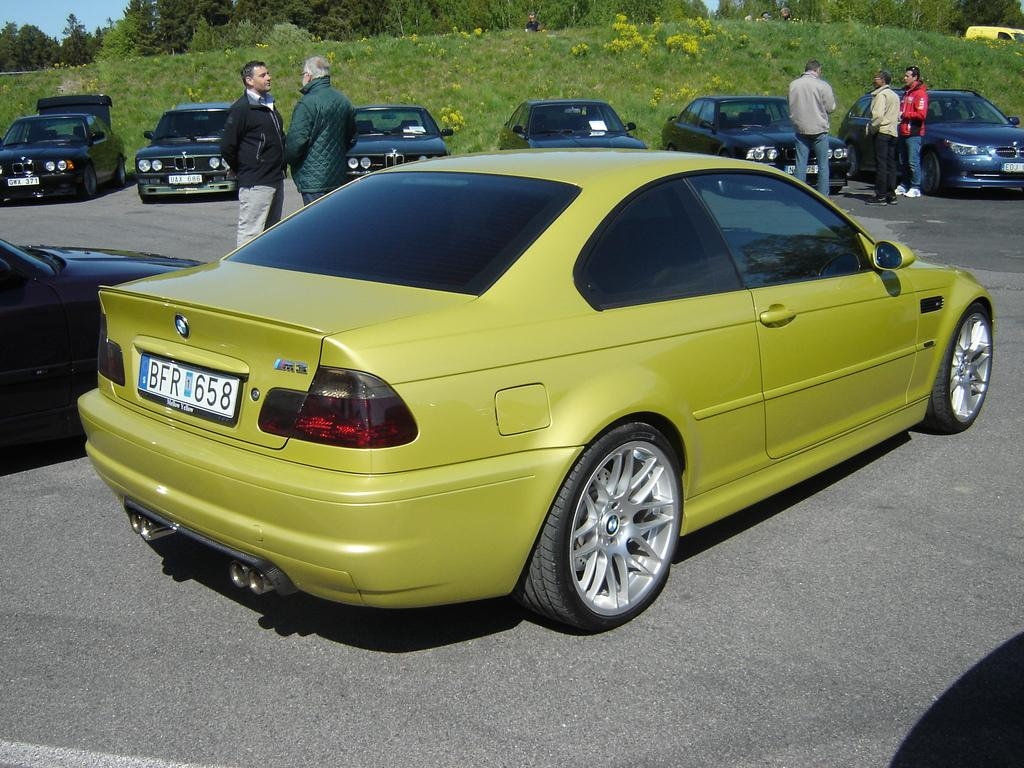What can be seen on the road in the image? There are vehicles on the road in the image. What else is present in the image besides the vehicles? There are persons standing in the image. What type of natural environment is visible in the background of the image? There are trees in the background of the image. What type of ground surface is visible in the image? There is grass on the ground in the image. What appliance can be seen in the image? There is no appliance present in the image. What holiday is being celebrated in the image? There is no indication of a holiday being celebrated in the image. 